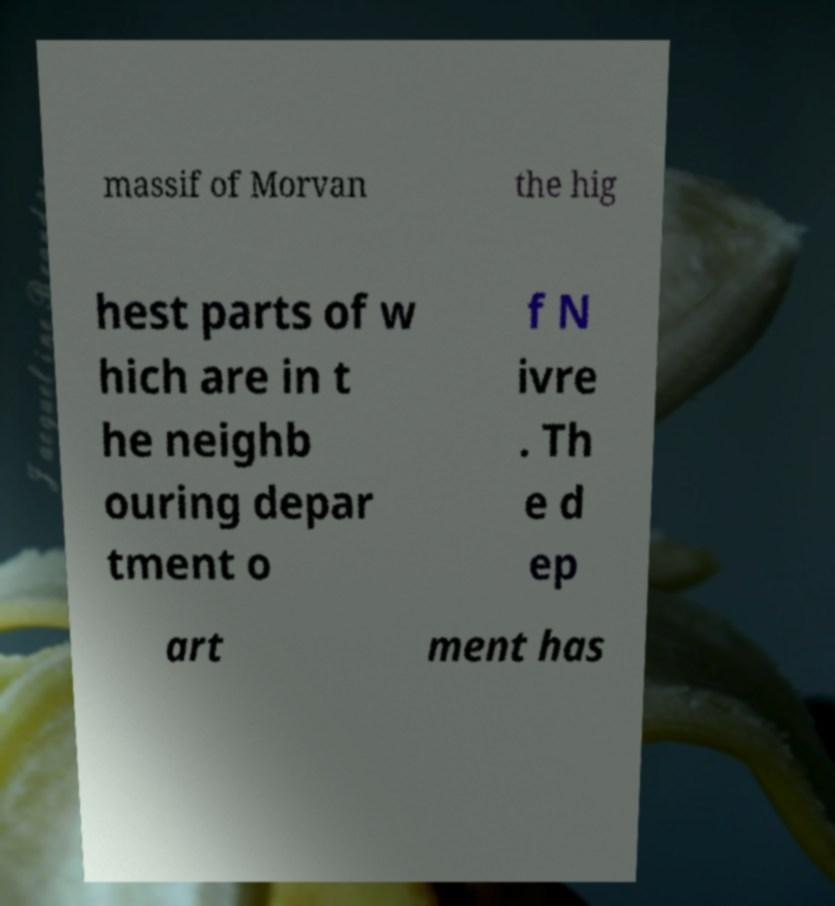Can you accurately transcribe the text from the provided image for me? massif of Morvan the hig hest parts of w hich are in t he neighb ouring depar tment o f N ivre . Th e d ep art ment has 